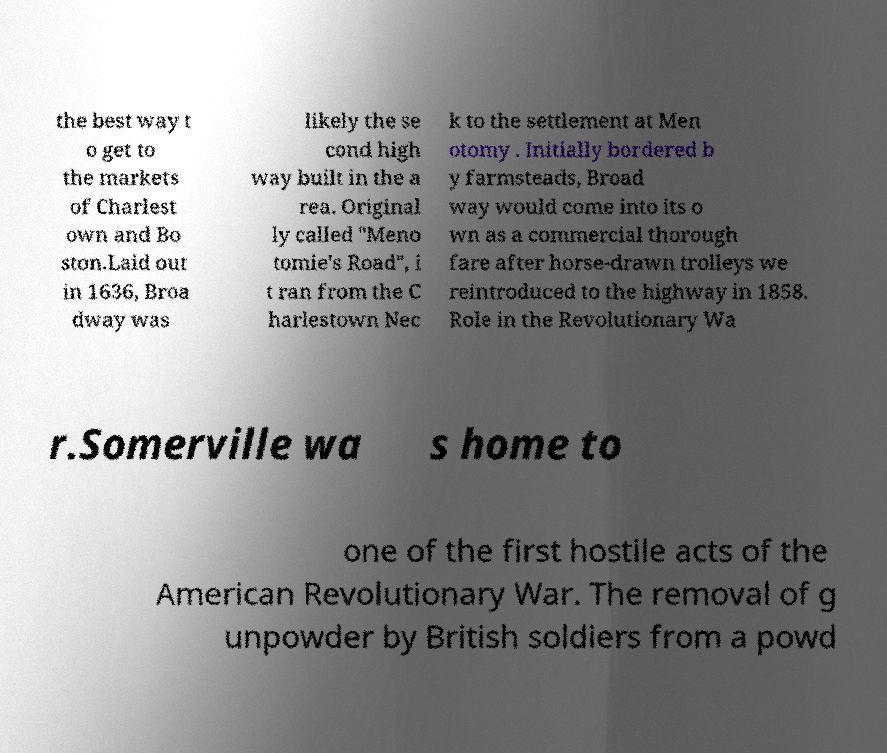For documentation purposes, I need the text within this image transcribed. Could you provide that? the best way t o get to the markets of Charlest own and Bo ston.Laid out in 1636, Broa dway was likely the se cond high way built in the a rea. Original ly called "Meno tomie's Road", i t ran from the C harlestown Nec k to the settlement at Men otomy . Initially bordered b y farmsteads, Broad way would come into its o wn as a commercial thorough fare after horse-drawn trolleys we reintroduced to the highway in 1858. Role in the Revolutionary Wa r.Somerville wa s home to one of the first hostile acts of the American Revolutionary War. The removal of g unpowder by British soldiers from a powd 